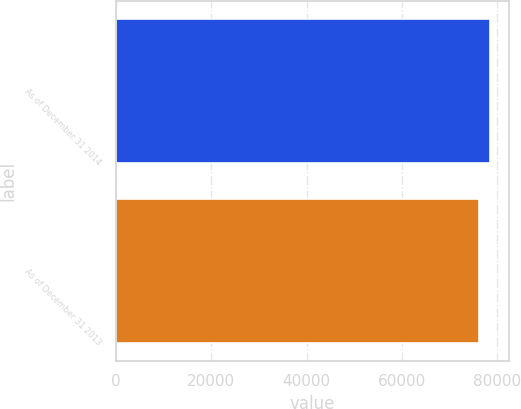Convert chart to OTSL. <chart><loc_0><loc_0><loc_500><loc_500><bar_chart><fcel>As of December 31 2014<fcel>As of December 31 2013<nl><fcel>78633<fcel>76214<nl></chart> 